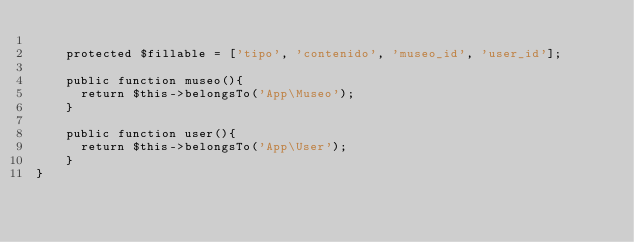<code> <loc_0><loc_0><loc_500><loc_500><_PHP_>
    protected $fillable = ['tipo', 'contenido', 'museo_id', 'user_id'];

    public function museo(){
    	return $this->belongsTo('App\Museo');
    }

    public function user(){
    	return $this->belongsTo('App\User');
    }
}
</code> 